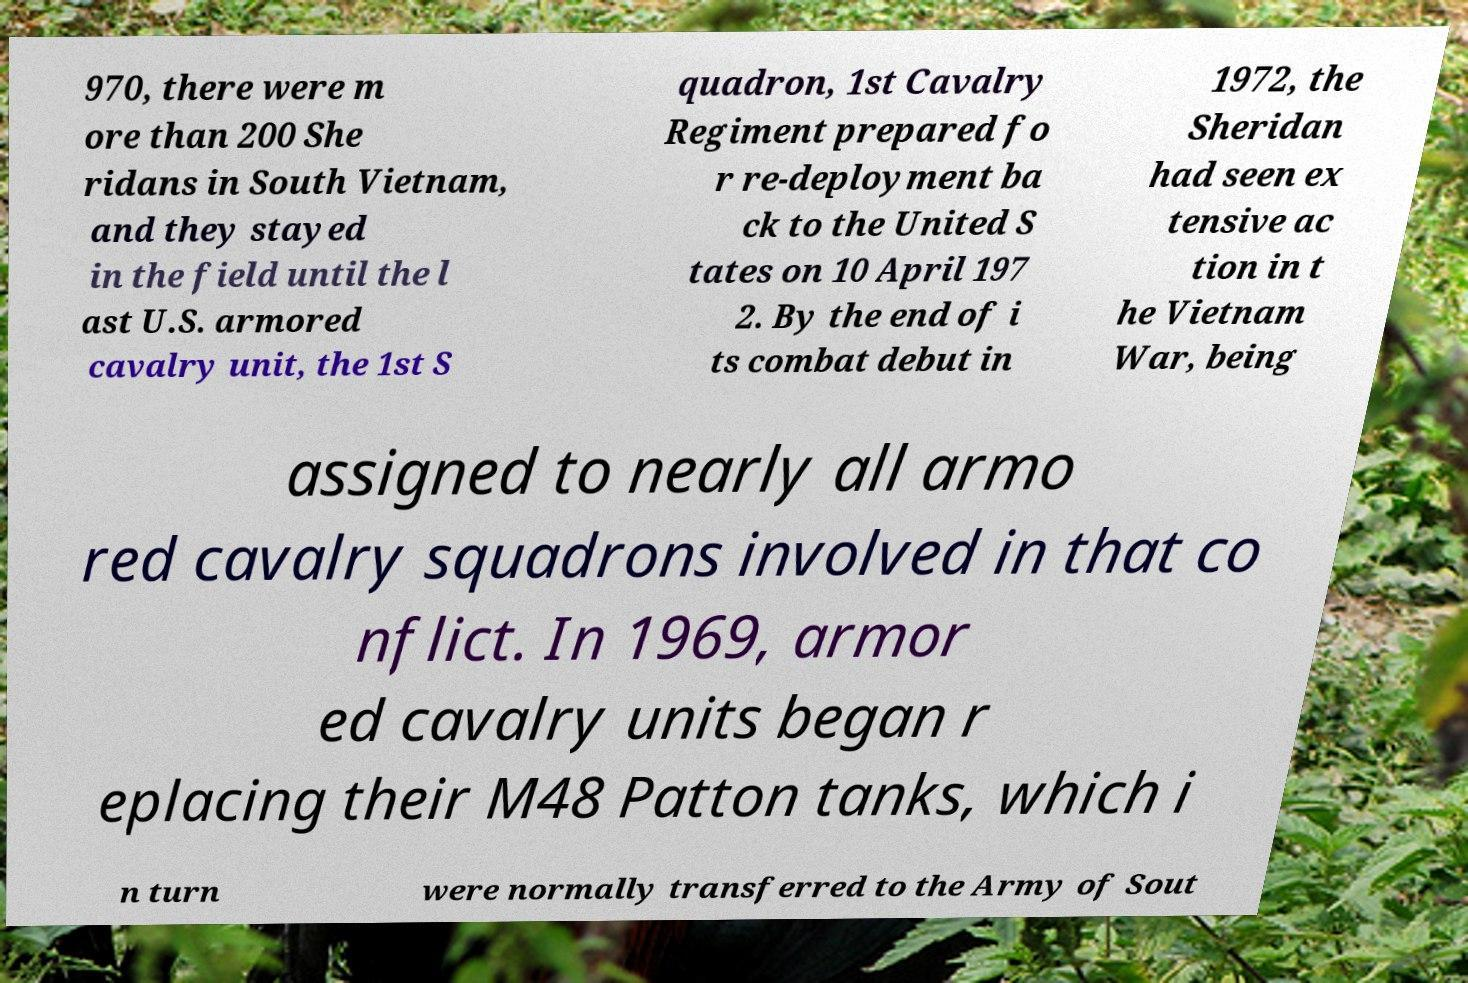Could you assist in decoding the text presented in this image and type it out clearly? 970, there were m ore than 200 She ridans in South Vietnam, and they stayed in the field until the l ast U.S. armored cavalry unit, the 1st S quadron, 1st Cavalry Regiment prepared fo r re-deployment ba ck to the United S tates on 10 April 197 2. By the end of i ts combat debut in 1972, the Sheridan had seen ex tensive ac tion in t he Vietnam War, being assigned to nearly all armo red cavalry squadrons involved in that co nflict. In 1969, armor ed cavalry units began r eplacing their M48 Patton tanks, which i n turn were normally transferred to the Army of Sout 